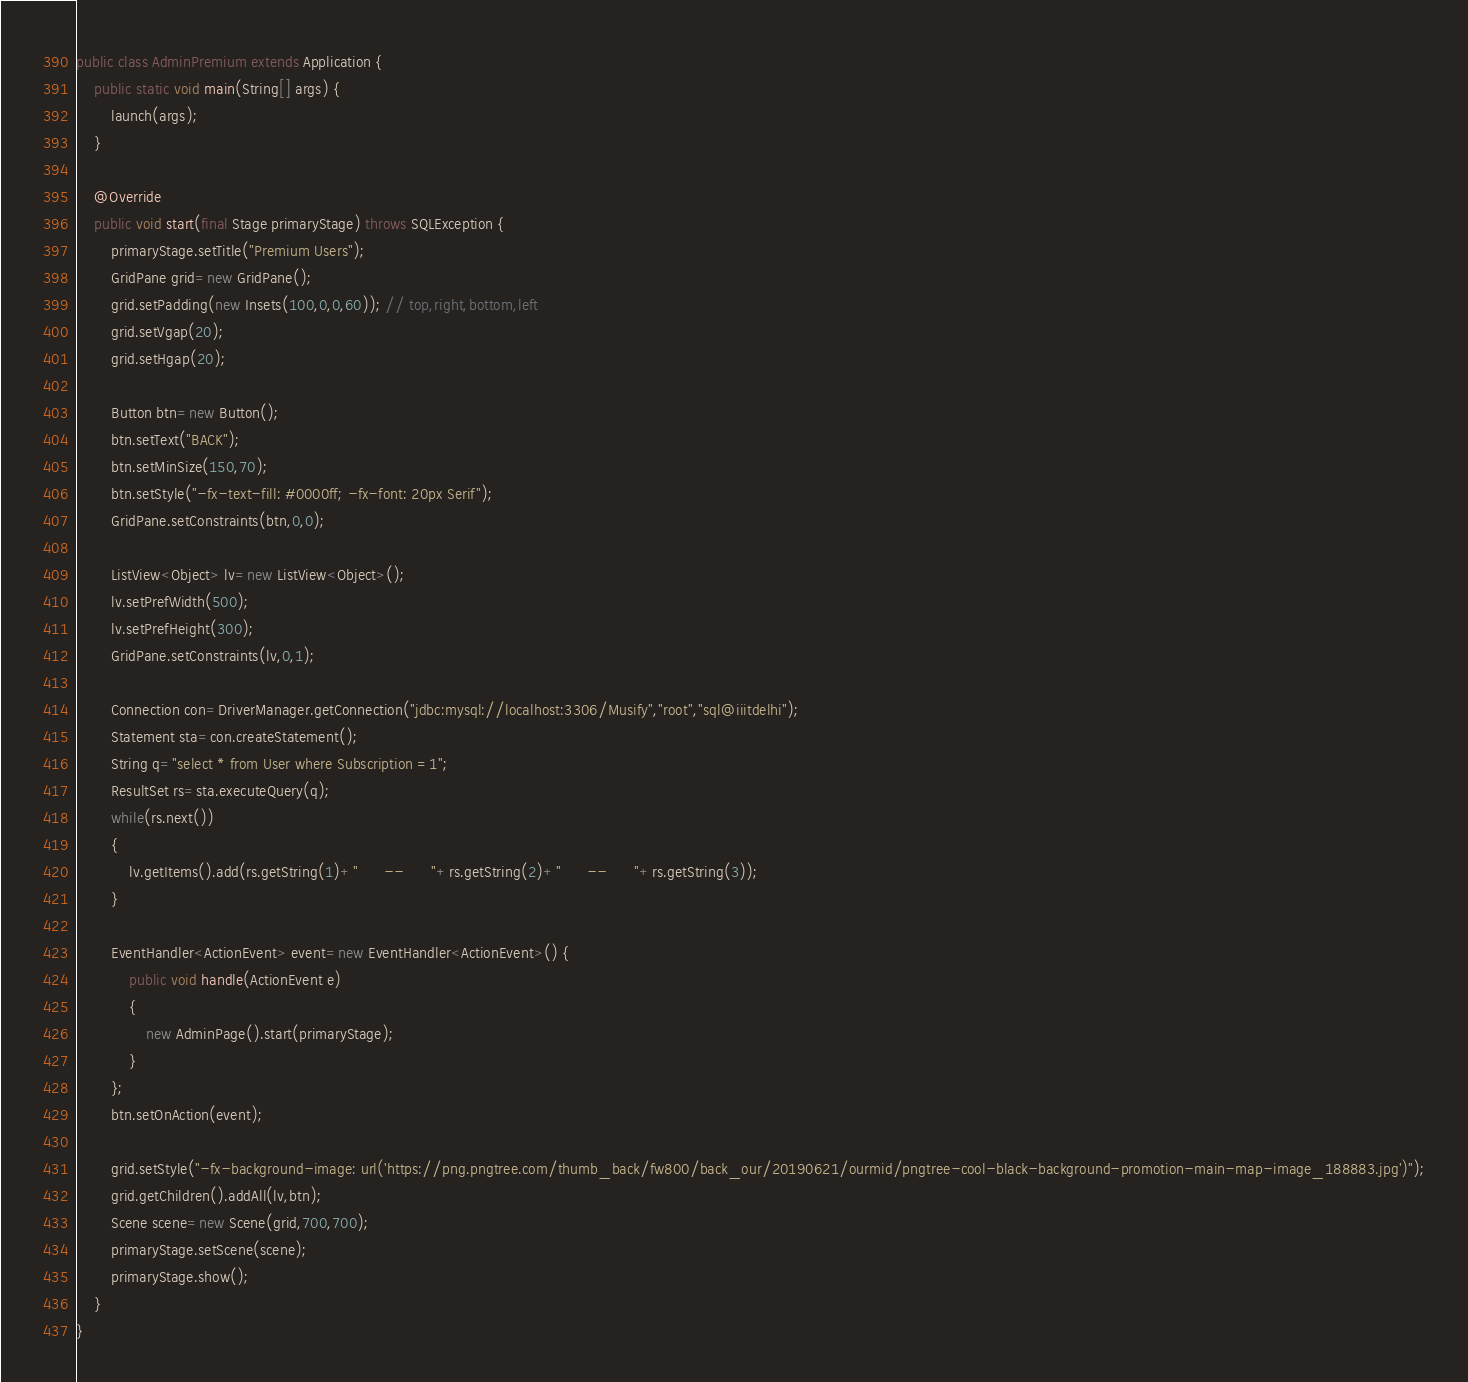<code> <loc_0><loc_0><loc_500><loc_500><_Java_>
public class AdminPremium extends Application {	 
	public static void main(String[] args) { 
        launch(args);
    } 
   
    @Override
    public void start(final Stage primaryStage) throws SQLException {
        primaryStage.setTitle("Premium Users");
        GridPane grid=new GridPane();
        grid.setPadding(new Insets(100,0,0,60)); // top,right,bottom,left
        grid.setVgap(20); 
        grid.setHgap(20); 
        
        Button btn=new Button(); 
        btn.setText("BACK");
        btn.setMinSize(150,70);
        btn.setStyle("-fx-text-fill: #0000ff; -fx-font: 20px Serif");
        GridPane.setConstraints(btn,0,0); 
                
        ListView<Object> lv=new ListView<Object>(); 
		lv.setPrefWidth(500);
		lv.setPrefHeight(300);  
		GridPane.setConstraints(lv,0,1);
		
        Connection con=DriverManager.getConnection("jdbc:mysql://localhost:3306/Musify","root","sql@iiitdelhi");
		Statement sta=con.createStatement();
		String q="select * from User where Subscription =1";
		ResultSet rs=sta.executeQuery(q);   
		while(rs.next())  
        {  
        	lv.getItems().add(rs.getString(1)+"      --      "+rs.getString(2)+"      --      "+rs.getString(3));
        } 
		  
		EventHandler<ActionEvent> event=new EventHandler<ActionEvent>() { 
            public void handle(ActionEvent e) 
            { 
            	new AdminPage().start(primaryStage);
            } 
        }; 
        btn.setOnAction(event);
        
        grid.setStyle("-fx-background-image: url('https://png.pngtree.com/thumb_back/fw800/back_our/20190621/ourmid/pngtree-cool-black-background-promotion-main-map-image_188883.jpg')");
	    grid.getChildren().addAll(lv,btn);
	    Scene scene=new Scene(grid,700,700);
		primaryStage.setScene(scene);	 
	    primaryStage.show();
    }
}</code> 